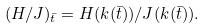Convert formula to latex. <formula><loc_0><loc_0><loc_500><loc_500>( H / J ) _ { \bar { t } } = H ( k ( \bar { t } ) ) / J ( k ( \bar { t } ) ) .</formula> 